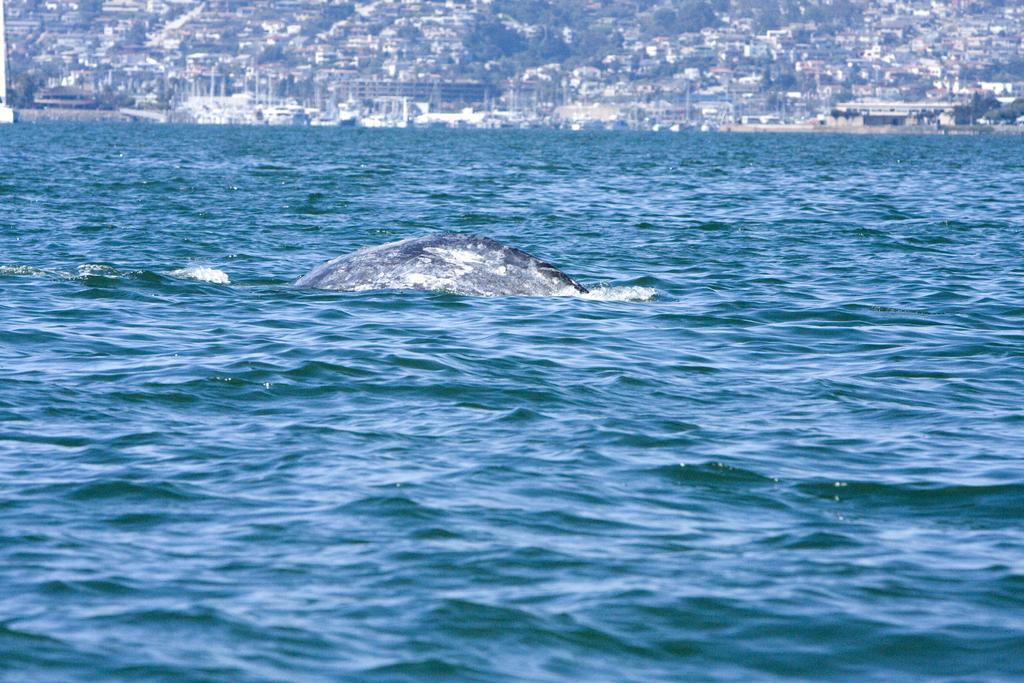What is visible in the image? Water is visible in the image. What can be seen in the background of the image? There are houses and trees in the background of the image. What type of trousers are being compared in the image? There are no trousers present in the image, and no comparison is being made. 